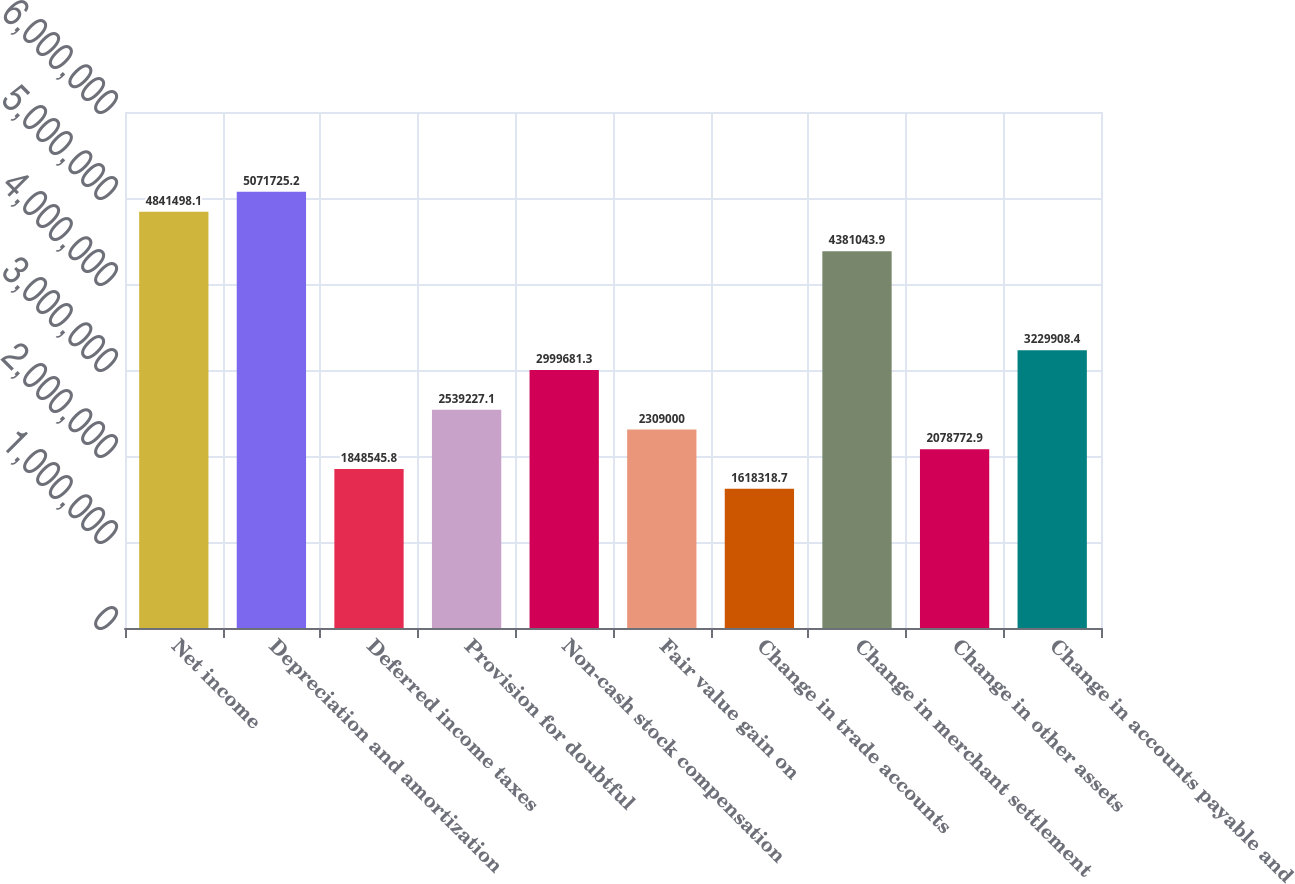Convert chart to OTSL. <chart><loc_0><loc_0><loc_500><loc_500><bar_chart><fcel>Net income<fcel>Depreciation and amortization<fcel>Deferred income taxes<fcel>Provision for doubtful<fcel>Non-cash stock compensation<fcel>Fair value gain on<fcel>Change in trade accounts<fcel>Change in merchant settlement<fcel>Change in other assets<fcel>Change in accounts payable and<nl><fcel>4.8415e+06<fcel>5.07173e+06<fcel>1.84855e+06<fcel>2.53923e+06<fcel>2.99968e+06<fcel>2.309e+06<fcel>1.61832e+06<fcel>4.38104e+06<fcel>2.07877e+06<fcel>3.22991e+06<nl></chart> 